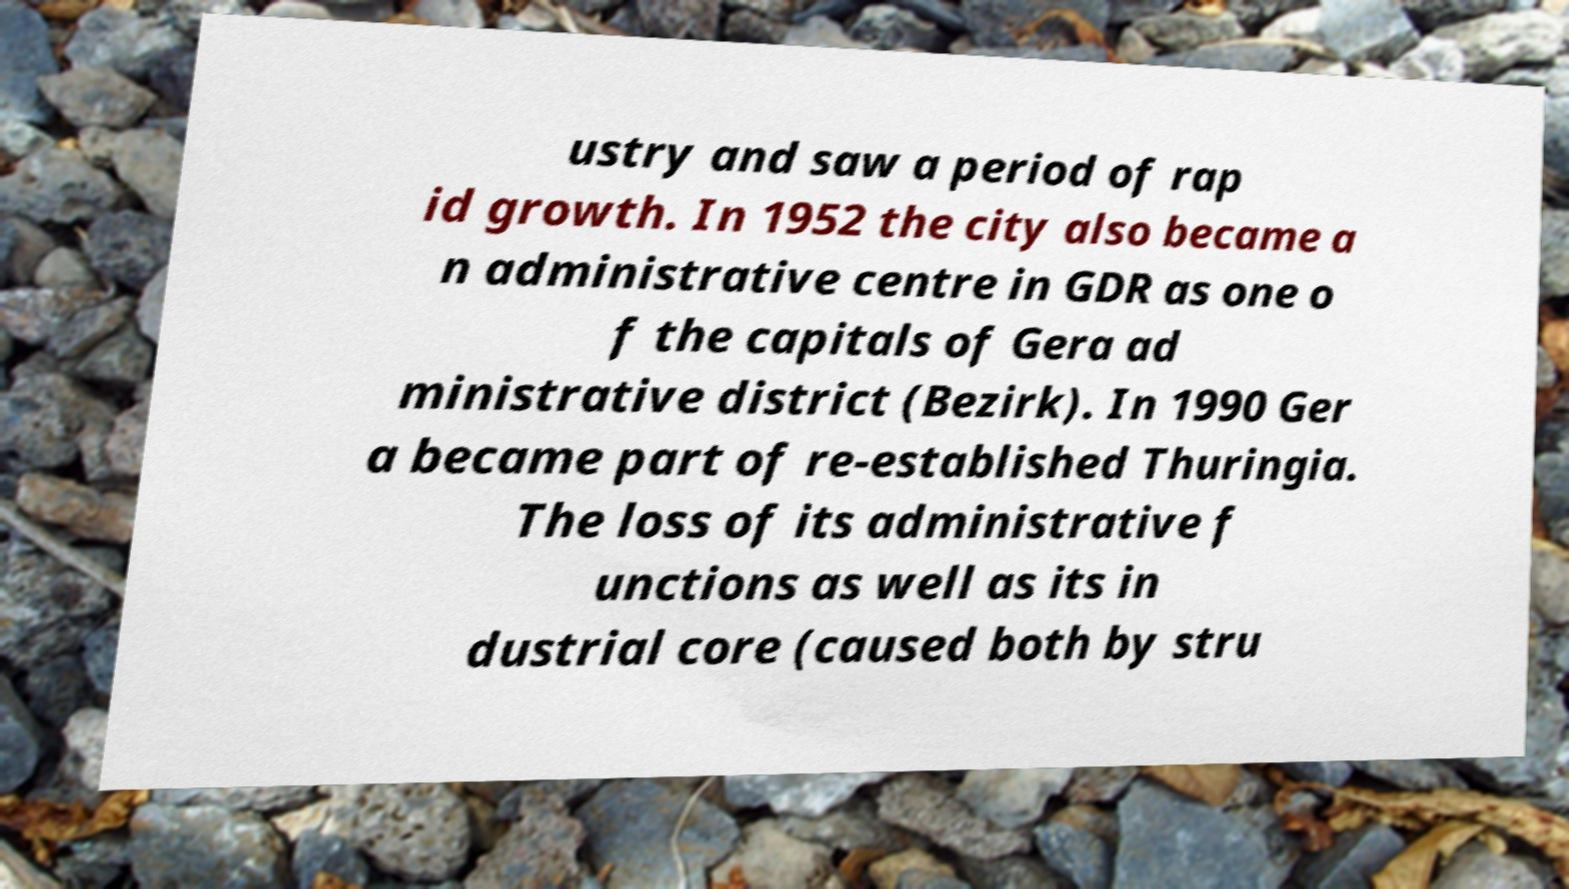Can you accurately transcribe the text from the provided image for me? ustry and saw a period of rap id growth. In 1952 the city also became a n administrative centre in GDR as one o f the capitals of Gera ad ministrative district (Bezirk). In 1990 Ger a became part of re-established Thuringia. The loss of its administrative f unctions as well as its in dustrial core (caused both by stru 